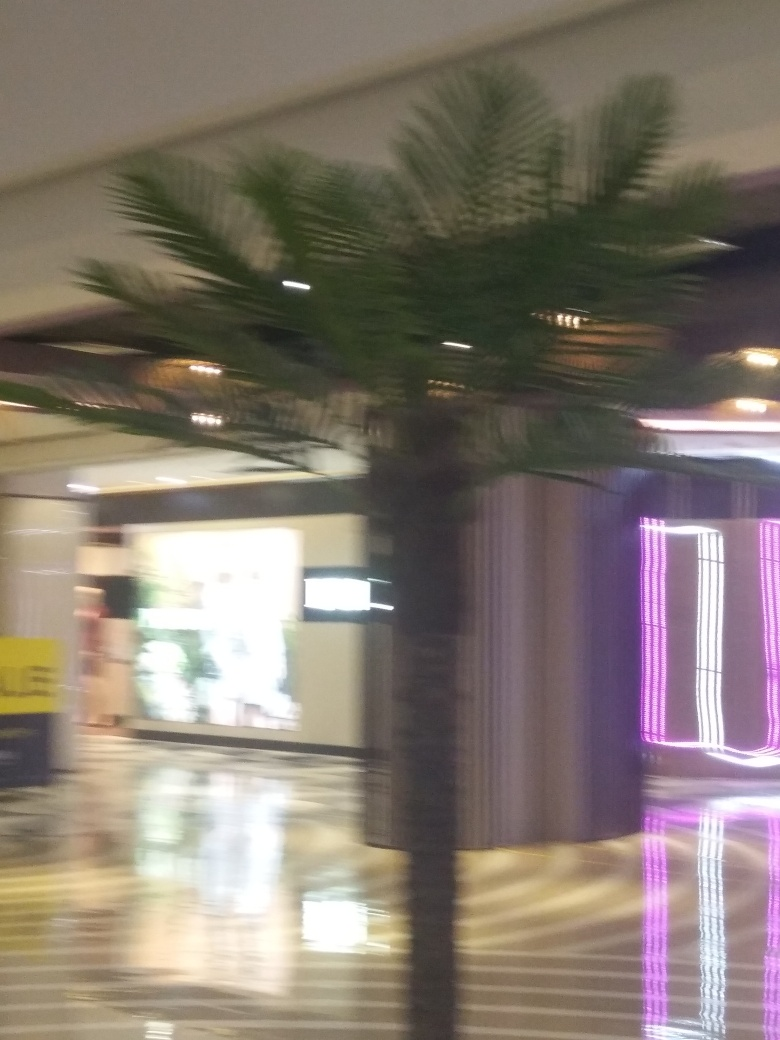What might have caused the blurriness in this photo? The blurriness in the photo could be due to several factors such as camera movement while the shot was being taken, slow shutter speed in a low-light condition, or perhaps an autofocus issue where the camera didn't lock onto a specific subject properly. Could this effect be used artistically? Absolutely. While typically seen as an error, motion blur or soft focus can be intentionally used to convey motion, create a sense of activity, or introduce an ethereal or dreamlike quality to the photo. It can also emphasize lighting conditions, as seen with the streaks from the neon lights in this image. 